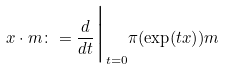<formula> <loc_0><loc_0><loc_500><loc_500>x \cdot m \colon = \frac { d } { d t } \Big | _ { t = 0 } \pi ( \exp ( t x ) ) m</formula> 